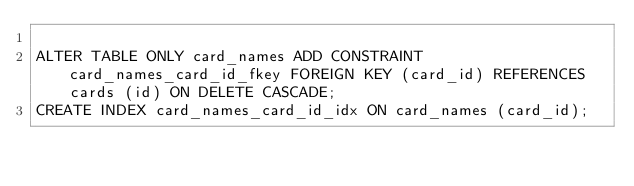<code> <loc_0><loc_0><loc_500><loc_500><_SQL_>
ALTER TABLE ONLY card_names ADD CONSTRAINT card_names_card_id_fkey FOREIGN KEY (card_id) REFERENCES cards (id) ON DELETE CASCADE;
CREATE INDEX card_names_card_id_idx ON card_names (card_id);
</code> 